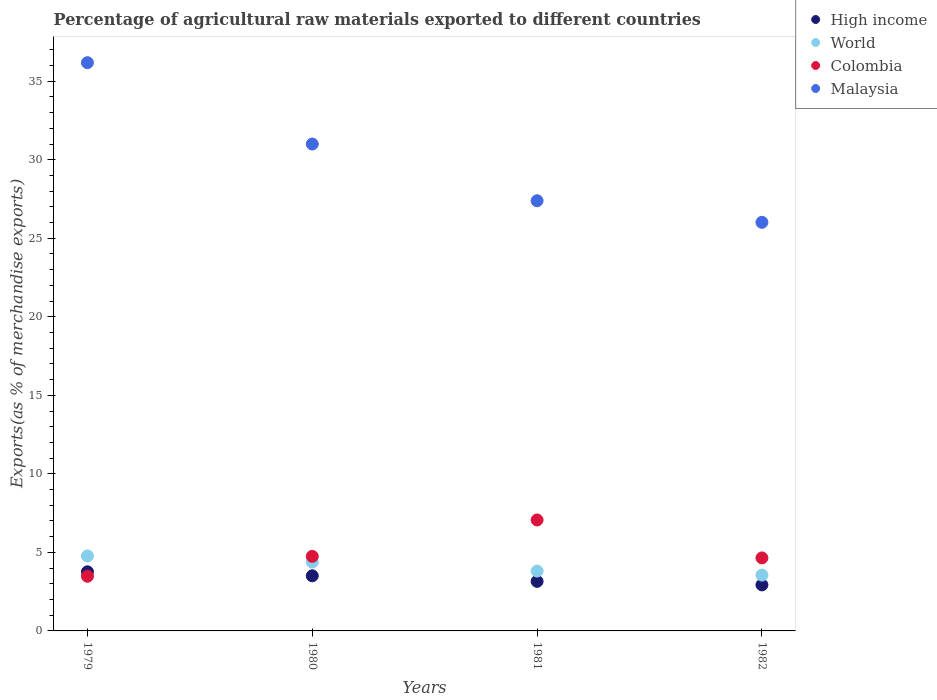How many different coloured dotlines are there?
Your answer should be compact. 4. Is the number of dotlines equal to the number of legend labels?
Keep it short and to the point. Yes. What is the percentage of exports to different countries in World in 1981?
Keep it short and to the point. 3.81. Across all years, what is the maximum percentage of exports to different countries in World?
Your response must be concise. 4.77. Across all years, what is the minimum percentage of exports to different countries in Malaysia?
Your answer should be very brief. 26.02. In which year was the percentage of exports to different countries in Malaysia maximum?
Your answer should be compact. 1979. In which year was the percentage of exports to different countries in High income minimum?
Your answer should be very brief. 1982. What is the total percentage of exports to different countries in Colombia in the graph?
Give a very brief answer. 19.94. What is the difference between the percentage of exports to different countries in World in 1979 and that in 1981?
Make the answer very short. 0.96. What is the difference between the percentage of exports to different countries in Colombia in 1979 and the percentage of exports to different countries in World in 1982?
Your answer should be compact. -0.07. What is the average percentage of exports to different countries in High income per year?
Your answer should be compact. 3.34. In the year 1982, what is the difference between the percentage of exports to different countries in High income and percentage of exports to different countries in Malaysia?
Your answer should be compact. -23.09. In how many years, is the percentage of exports to different countries in High income greater than 16 %?
Your response must be concise. 0. What is the ratio of the percentage of exports to different countries in World in 1979 to that in 1982?
Keep it short and to the point. 1.34. Is the percentage of exports to different countries in High income in 1979 less than that in 1982?
Offer a terse response. No. Is the difference between the percentage of exports to different countries in High income in 1979 and 1982 greater than the difference between the percentage of exports to different countries in Malaysia in 1979 and 1982?
Your response must be concise. No. What is the difference between the highest and the second highest percentage of exports to different countries in Colombia?
Ensure brevity in your answer.  2.32. What is the difference between the highest and the lowest percentage of exports to different countries in High income?
Offer a very short reply. 0.83. In how many years, is the percentage of exports to different countries in High income greater than the average percentage of exports to different countries in High income taken over all years?
Offer a terse response. 2. Is the sum of the percentage of exports to different countries in Malaysia in 1980 and 1981 greater than the maximum percentage of exports to different countries in World across all years?
Ensure brevity in your answer.  Yes. Is it the case that in every year, the sum of the percentage of exports to different countries in World and percentage of exports to different countries in Malaysia  is greater than the sum of percentage of exports to different countries in High income and percentage of exports to different countries in Colombia?
Make the answer very short. No. How many dotlines are there?
Make the answer very short. 4. How many years are there in the graph?
Provide a succinct answer. 4. What is the difference between two consecutive major ticks on the Y-axis?
Offer a terse response. 5. Are the values on the major ticks of Y-axis written in scientific E-notation?
Your answer should be very brief. No. Does the graph contain any zero values?
Provide a succinct answer. No. Does the graph contain grids?
Offer a very short reply. No. Where does the legend appear in the graph?
Offer a very short reply. Top right. How many legend labels are there?
Offer a very short reply. 4. How are the legend labels stacked?
Your answer should be compact. Vertical. What is the title of the graph?
Keep it short and to the point. Percentage of agricultural raw materials exported to different countries. What is the label or title of the X-axis?
Your response must be concise. Years. What is the label or title of the Y-axis?
Provide a succinct answer. Exports(as % of merchandise exports). What is the Exports(as % of merchandise exports) in High income in 1979?
Your response must be concise. 3.76. What is the Exports(as % of merchandise exports) in World in 1979?
Offer a very short reply. 4.77. What is the Exports(as % of merchandise exports) in Colombia in 1979?
Ensure brevity in your answer.  3.48. What is the Exports(as % of merchandise exports) in Malaysia in 1979?
Your response must be concise. 36.18. What is the Exports(as % of merchandise exports) of High income in 1980?
Make the answer very short. 3.51. What is the Exports(as % of merchandise exports) of World in 1980?
Give a very brief answer. 4.38. What is the Exports(as % of merchandise exports) of Colombia in 1980?
Your answer should be very brief. 4.75. What is the Exports(as % of merchandise exports) in Malaysia in 1980?
Make the answer very short. 31. What is the Exports(as % of merchandise exports) of High income in 1981?
Provide a succinct answer. 3.16. What is the Exports(as % of merchandise exports) in World in 1981?
Your answer should be compact. 3.81. What is the Exports(as % of merchandise exports) of Colombia in 1981?
Ensure brevity in your answer.  7.07. What is the Exports(as % of merchandise exports) in Malaysia in 1981?
Ensure brevity in your answer.  27.39. What is the Exports(as % of merchandise exports) of High income in 1982?
Provide a succinct answer. 2.93. What is the Exports(as % of merchandise exports) of World in 1982?
Your answer should be compact. 3.55. What is the Exports(as % of merchandise exports) in Colombia in 1982?
Your answer should be very brief. 4.65. What is the Exports(as % of merchandise exports) in Malaysia in 1982?
Your answer should be compact. 26.02. Across all years, what is the maximum Exports(as % of merchandise exports) in High income?
Ensure brevity in your answer.  3.76. Across all years, what is the maximum Exports(as % of merchandise exports) in World?
Your response must be concise. 4.77. Across all years, what is the maximum Exports(as % of merchandise exports) of Colombia?
Your response must be concise. 7.07. Across all years, what is the maximum Exports(as % of merchandise exports) of Malaysia?
Keep it short and to the point. 36.18. Across all years, what is the minimum Exports(as % of merchandise exports) of High income?
Offer a very short reply. 2.93. Across all years, what is the minimum Exports(as % of merchandise exports) in World?
Make the answer very short. 3.55. Across all years, what is the minimum Exports(as % of merchandise exports) of Colombia?
Offer a terse response. 3.48. Across all years, what is the minimum Exports(as % of merchandise exports) of Malaysia?
Provide a succinct answer. 26.02. What is the total Exports(as % of merchandise exports) of High income in the graph?
Your response must be concise. 13.36. What is the total Exports(as % of merchandise exports) in World in the graph?
Keep it short and to the point. 16.52. What is the total Exports(as % of merchandise exports) in Colombia in the graph?
Provide a succinct answer. 19.94. What is the total Exports(as % of merchandise exports) of Malaysia in the graph?
Provide a succinct answer. 120.59. What is the difference between the Exports(as % of merchandise exports) in High income in 1979 and that in 1980?
Provide a short and direct response. 0.26. What is the difference between the Exports(as % of merchandise exports) of World in 1979 and that in 1980?
Offer a very short reply. 0.39. What is the difference between the Exports(as % of merchandise exports) of Colombia in 1979 and that in 1980?
Keep it short and to the point. -1.27. What is the difference between the Exports(as % of merchandise exports) of Malaysia in 1979 and that in 1980?
Make the answer very short. 5.18. What is the difference between the Exports(as % of merchandise exports) in High income in 1979 and that in 1981?
Give a very brief answer. 0.61. What is the difference between the Exports(as % of merchandise exports) in World in 1979 and that in 1981?
Provide a succinct answer. 0.96. What is the difference between the Exports(as % of merchandise exports) in Colombia in 1979 and that in 1981?
Make the answer very short. -3.58. What is the difference between the Exports(as % of merchandise exports) in Malaysia in 1979 and that in 1981?
Offer a very short reply. 8.79. What is the difference between the Exports(as % of merchandise exports) in High income in 1979 and that in 1982?
Give a very brief answer. 0.83. What is the difference between the Exports(as % of merchandise exports) of World in 1979 and that in 1982?
Make the answer very short. 1.22. What is the difference between the Exports(as % of merchandise exports) of Colombia in 1979 and that in 1982?
Provide a succinct answer. -1.17. What is the difference between the Exports(as % of merchandise exports) in Malaysia in 1979 and that in 1982?
Your answer should be compact. 10.16. What is the difference between the Exports(as % of merchandise exports) of High income in 1980 and that in 1981?
Ensure brevity in your answer.  0.35. What is the difference between the Exports(as % of merchandise exports) in World in 1980 and that in 1981?
Offer a very short reply. 0.57. What is the difference between the Exports(as % of merchandise exports) of Colombia in 1980 and that in 1981?
Provide a short and direct response. -2.32. What is the difference between the Exports(as % of merchandise exports) in Malaysia in 1980 and that in 1981?
Keep it short and to the point. 3.61. What is the difference between the Exports(as % of merchandise exports) of High income in 1980 and that in 1982?
Keep it short and to the point. 0.58. What is the difference between the Exports(as % of merchandise exports) of World in 1980 and that in 1982?
Provide a short and direct response. 0.83. What is the difference between the Exports(as % of merchandise exports) in Colombia in 1980 and that in 1982?
Provide a short and direct response. 0.1. What is the difference between the Exports(as % of merchandise exports) of Malaysia in 1980 and that in 1982?
Give a very brief answer. 4.98. What is the difference between the Exports(as % of merchandise exports) of High income in 1981 and that in 1982?
Provide a short and direct response. 0.23. What is the difference between the Exports(as % of merchandise exports) in World in 1981 and that in 1982?
Your answer should be compact. 0.26. What is the difference between the Exports(as % of merchandise exports) of Colombia in 1981 and that in 1982?
Give a very brief answer. 2.42. What is the difference between the Exports(as % of merchandise exports) of Malaysia in 1981 and that in 1982?
Your answer should be compact. 1.37. What is the difference between the Exports(as % of merchandise exports) in High income in 1979 and the Exports(as % of merchandise exports) in World in 1980?
Your answer should be compact. -0.62. What is the difference between the Exports(as % of merchandise exports) in High income in 1979 and the Exports(as % of merchandise exports) in Colombia in 1980?
Offer a very short reply. -0.98. What is the difference between the Exports(as % of merchandise exports) of High income in 1979 and the Exports(as % of merchandise exports) of Malaysia in 1980?
Provide a succinct answer. -27.24. What is the difference between the Exports(as % of merchandise exports) in World in 1979 and the Exports(as % of merchandise exports) in Colombia in 1980?
Give a very brief answer. 0.03. What is the difference between the Exports(as % of merchandise exports) in World in 1979 and the Exports(as % of merchandise exports) in Malaysia in 1980?
Make the answer very short. -26.23. What is the difference between the Exports(as % of merchandise exports) in Colombia in 1979 and the Exports(as % of merchandise exports) in Malaysia in 1980?
Ensure brevity in your answer.  -27.52. What is the difference between the Exports(as % of merchandise exports) of High income in 1979 and the Exports(as % of merchandise exports) of World in 1981?
Make the answer very short. -0.05. What is the difference between the Exports(as % of merchandise exports) in High income in 1979 and the Exports(as % of merchandise exports) in Colombia in 1981?
Ensure brevity in your answer.  -3.3. What is the difference between the Exports(as % of merchandise exports) of High income in 1979 and the Exports(as % of merchandise exports) of Malaysia in 1981?
Make the answer very short. -23.63. What is the difference between the Exports(as % of merchandise exports) of World in 1979 and the Exports(as % of merchandise exports) of Colombia in 1981?
Offer a terse response. -2.29. What is the difference between the Exports(as % of merchandise exports) in World in 1979 and the Exports(as % of merchandise exports) in Malaysia in 1981?
Provide a succinct answer. -22.62. What is the difference between the Exports(as % of merchandise exports) of Colombia in 1979 and the Exports(as % of merchandise exports) of Malaysia in 1981?
Your answer should be compact. -23.91. What is the difference between the Exports(as % of merchandise exports) in High income in 1979 and the Exports(as % of merchandise exports) in World in 1982?
Give a very brief answer. 0.21. What is the difference between the Exports(as % of merchandise exports) in High income in 1979 and the Exports(as % of merchandise exports) in Colombia in 1982?
Provide a succinct answer. -0.88. What is the difference between the Exports(as % of merchandise exports) of High income in 1979 and the Exports(as % of merchandise exports) of Malaysia in 1982?
Your answer should be very brief. -22.25. What is the difference between the Exports(as % of merchandise exports) of World in 1979 and the Exports(as % of merchandise exports) of Colombia in 1982?
Provide a short and direct response. 0.13. What is the difference between the Exports(as % of merchandise exports) in World in 1979 and the Exports(as % of merchandise exports) in Malaysia in 1982?
Give a very brief answer. -21.24. What is the difference between the Exports(as % of merchandise exports) in Colombia in 1979 and the Exports(as % of merchandise exports) in Malaysia in 1982?
Make the answer very short. -22.54. What is the difference between the Exports(as % of merchandise exports) in High income in 1980 and the Exports(as % of merchandise exports) in World in 1981?
Ensure brevity in your answer.  -0.3. What is the difference between the Exports(as % of merchandise exports) of High income in 1980 and the Exports(as % of merchandise exports) of Colombia in 1981?
Provide a short and direct response. -3.56. What is the difference between the Exports(as % of merchandise exports) of High income in 1980 and the Exports(as % of merchandise exports) of Malaysia in 1981?
Your answer should be very brief. -23.88. What is the difference between the Exports(as % of merchandise exports) in World in 1980 and the Exports(as % of merchandise exports) in Colombia in 1981?
Ensure brevity in your answer.  -2.68. What is the difference between the Exports(as % of merchandise exports) in World in 1980 and the Exports(as % of merchandise exports) in Malaysia in 1981?
Your response must be concise. -23.01. What is the difference between the Exports(as % of merchandise exports) of Colombia in 1980 and the Exports(as % of merchandise exports) of Malaysia in 1981?
Keep it short and to the point. -22.64. What is the difference between the Exports(as % of merchandise exports) in High income in 1980 and the Exports(as % of merchandise exports) in World in 1982?
Give a very brief answer. -0.05. What is the difference between the Exports(as % of merchandise exports) of High income in 1980 and the Exports(as % of merchandise exports) of Colombia in 1982?
Give a very brief answer. -1.14. What is the difference between the Exports(as % of merchandise exports) in High income in 1980 and the Exports(as % of merchandise exports) in Malaysia in 1982?
Your response must be concise. -22.51. What is the difference between the Exports(as % of merchandise exports) of World in 1980 and the Exports(as % of merchandise exports) of Colombia in 1982?
Your answer should be compact. -0.27. What is the difference between the Exports(as % of merchandise exports) of World in 1980 and the Exports(as % of merchandise exports) of Malaysia in 1982?
Keep it short and to the point. -21.63. What is the difference between the Exports(as % of merchandise exports) in Colombia in 1980 and the Exports(as % of merchandise exports) in Malaysia in 1982?
Your answer should be very brief. -21.27. What is the difference between the Exports(as % of merchandise exports) of High income in 1981 and the Exports(as % of merchandise exports) of World in 1982?
Ensure brevity in your answer.  -0.4. What is the difference between the Exports(as % of merchandise exports) in High income in 1981 and the Exports(as % of merchandise exports) in Colombia in 1982?
Your response must be concise. -1.49. What is the difference between the Exports(as % of merchandise exports) of High income in 1981 and the Exports(as % of merchandise exports) of Malaysia in 1982?
Provide a short and direct response. -22.86. What is the difference between the Exports(as % of merchandise exports) in World in 1981 and the Exports(as % of merchandise exports) in Colombia in 1982?
Ensure brevity in your answer.  -0.84. What is the difference between the Exports(as % of merchandise exports) of World in 1981 and the Exports(as % of merchandise exports) of Malaysia in 1982?
Provide a succinct answer. -22.21. What is the difference between the Exports(as % of merchandise exports) of Colombia in 1981 and the Exports(as % of merchandise exports) of Malaysia in 1982?
Your answer should be very brief. -18.95. What is the average Exports(as % of merchandise exports) in High income per year?
Offer a very short reply. 3.34. What is the average Exports(as % of merchandise exports) of World per year?
Provide a short and direct response. 4.13. What is the average Exports(as % of merchandise exports) in Colombia per year?
Ensure brevity in your answer.  4.99. What is the average Exports(as % of merchandise exports) of Malaysia per year?
Provide a succinct answer. 30.15. In the year 1979, what is the difference between the Exports(as % of merchandise exports) of High income and Exports(as % of merchandise exports) of World?
Provide a succinct answer. -1.01. In the year 1979, what is the difference between the Exports(as % of merchandise exports) in High income and Exports(as % of merchandise exports) in Colombia?
Your answer should be compact. 0.28. In the year 1979, what is the difference between the Exports(as % of merchandise exports) in High income and Exports(as % of merchandise exports) in Malaysia?
Offer a terse response. -32.42. In the year 1979, what is the difference between the Exports(as % of merchandise exports) of World and Exports(as % of merchandise exports) of Colombia?
Your response must be concise. 1.29. In the year 1979, what is the difference between the Exports(as % of merchandise exports) of World and Exports(as % of merchandise exports) of Malaysia?
Provide a short and direct response. -31.41. In the year 1979, what is the difference between the Exports(as % of merchandise exports) in Colombia and Exports(as % of merchandise exports) in Malaysia?
Keep it short and to the point. -32.7. In the year 1980, what is the difference between the Exports(as % of merchandise exports) of High income and Exports(as % of merchandise exports) of World?
Give a very brief answer. -0.87. In the year 1980, what is the difference between the Exports(as % of merchandise exports) of High income and Exports(as % of merchandise exports) of Colombia?
Give a very brief answer. -1.24. In the year 1980, what is the difference between the Exports(as % of merchandise exports) of High income and Exports(as % of merchandise exports) of Malaysia?
Provide a short and direct response. -27.49. In the year 1980, what is the difference between the Exports(as % of merchandise exports) of World and Exports(as % of merchandise exports) of Colombia?
Provide a short and direct response. -0.36. In the year 1980, what is the difference between the Exports(as % of merchandise exports) in World and Exports(as % of merchandise exports) in Malaysia?
Your answer should be very brief. -26.62. In the year 1980, what is the difference between the Exports(as % of merchandise exports) in Colombia and Exports(as % of merchandise exports) in Malaysia?
Provide a short and direct response. -26.25. In the year 1981, what is the difference between the Exports(as % of merchandise exports) in High income and Exports(as % of merchandise exports) in World?
Provide a succinct answer. -0.65. In the year 1981, what is the difference between the Exports(as % of merchandise exports) of High income and Exports(as % of merchandise exports) of Colombia?
Provide a succinct answer. -3.91. In the year 1981, what is the difference between the Exports(as % of merchandise exports) in High income and Exports(as % of merchandise exports) in Malaysia?
Keep it short and to the point. -24.23. In the year 1981, what is the difference between the Exports(as % of merchandise exports) of World and Exports(as % of merchandise exports) of Colombia?
Make the answer very short. -3.25. In the year 1981, what is the difference between the Exports(as % of merchandise exports) of World and Exports(as % of merchandise exports) of Malaysia?
Offer a very short reply. -23.58. In the year 1981, what is the difference between the Exports(as % of merchandise exports) in Colombia and Exports(as % of merchandise exports) in Malaysia?
Offer a terse response. -20.33. In the year 1982, what is the difference between the Exports(as % of merchandise exports) of High income and Exports(as % of merchandise exports) of World?
Provide a short and direct response. -0.62. In the year 1982, what is the difference between the Exports(as % of merchandise exports) in High income and Exports(as % of merchandise exports) in Colombia?
Your answer should be compact. -1.72. In the year 1982, what is the difference between the Exports(as % of merchandise exports) in High income and Exports(as % of merchandise exports) in Malaysia?
Keep it short and to the point. -23.09. In the year 1982, what is the difference between the Exports(as % of merchandise exports) of World and Exports(as % of merchandise exports) of Colombia?
Your response must be concise. -1.09. In the year 1982, what is the difference between the Exports(as % of merchandise exports) of World and Exports(as % of merchandise exports) of Malaysia?
Provide a succinct answer. -22.46. In the year 1982, what is the difference between the Exports(as % of merchandise exports) in Colombia and Exports(as % of merchandise exports) in Malaysia?
Ensure brevity in your answer.  -21.37. What is the ratio of the Exports(as % of merchandise exports) of High income in 1979 to that in 1980?
Offer a terse response. 1.07. What is the ratio of the Exports(as % of merchandise exports) in World in 1979 to that in 1980?
Keep it short and to the point. 1.09. What is the ratio of the Exports(as % of merchandise exports) of Colombia in 1979 to that in 1980?
Your answer should be very brief. 0.73. What is the ratio of the Exports(as % of merchandise exports) in Malaysia in 1979 to that in 1980?
Offer a very short reply. 1.17. What is the ratio of the Exports(as % of merchandise exports) in High income in 1979 to that in 1981?
Keep it short and to the point. 1.19. What is the ratio of the Exports(as % of merchandise exports) of World in 1979 to that in 1981?
Give a very brief answer. 1.25. What is the ratio of the Exports(as % of merchandise exports) of Colombia in 1979 to that in 1981?
Make the answer very short. 0.49. What is the ratio of the Exports(as % of merchandise exports) in Malaysia in 1979 to that in 1981?
Your answer should be very brief. 1.32. What is the ratio of the Exports(as % of merchandise exports) in High income in 1979 to that in 1982?
Provide a short and direct response. 1.28. What is the ratio of the Exports(as % of merchandise exports) in World in 1979 to that in 1982?
Keep it short and to the point. 1.34. What is the ratio of the Exports(as % of merchandise exports) of Colombia in 1979 to that in 1982?
Offer a very short reply. 0.75. What is the ratio of the Exports(as % of merchandise exports) of Malaysia in 1979 to that in 1982?
Give a very brief answer. 1.39. What is the ratio of the Exports(as % of merchandise exports) in High income in 1980 to that in 1981?
Provide a short and direct response. 1.11. What is the ratio of the Exports(as % of merchandise exports) of World in 1980 to that in 1981?
Your answer should be compact. 1.15. What is the ratio of the Exports(as % of merchandise exports) in Colombia in 1980 to that in 1981?
Your response must be concise. 0.67. What is the ratio of the Exports(as % of merchandise exports) in Malaysia in 1980 to that in 1981?
Make the answer very short. 1.13. What is the ratio of the Exports(as % of merchandise exports) of High income in 1980 to that in 1982?
Offer a terse response. 1.2. What is the ratio of the Exports(as % of merchandise exports) of World in 1980 to that in 1982?
Offer a terse response. 1.23. What is the ratio of the Exports(as % of merchandise exports) of Colombia in 1980 to that in 1982?
Your response must be concise. 1.02. What is the ratio of the Exports(as % of merchandise exports) in Malaysia in 1980 to that in 1982?
Give a very brief answer. 1.19. What is the ratio of the Exports(as % of merchandise exports) of High income in 1981 to that in 1982?
Provide a short and direct response. 1.08. What is the ratio of the Exports(as % of merchandise exports) in World in 1981 to that in 1982?
Keep it short and to the point. 1.07. What is the ratio of the Exports(as % of merchandise exports) of Colombia in 1981 to that in 1982?
Offer a very short reply. 1.52. What is the ratio of the Exports(as % of merchandise exports) in Malaysia in 1981 to that in 1982?
Your response must be concise. 1.05. What is the difference between the highest and the second highest Exports(as % of merchandise exports) in High income?
Your answer should be very brief. 0.26. What is the difference between the highest and the second highest Exports(as % of merchandise exports) of World?
Keep it short and to the point. 0.39. What is the difference between the highest and the second highest Exports(as % of merchandise exports) of Colombia?
Offer a very short reply. 2.32. What is the difference between the highest and the second highest Exports(as % of merchandise exports) in Malaysia?
Your answer should be very brief. 5.18. What is the difference between the highest and the lowest Exports(as % of merchandise exports) in High income?
Your response must be concise. 0.83. What is the difference between the highest and the lowest Exports(as % of merchandise exports) of World?
Ensure brevity in your answer.  1.22. What is the difference between the highest and the lowest Exports(as % of merchandise exports) in Colombia?
Your response must be concise. 3.58. What is the difference between the highest and the lowest Exports(as % of merchandise exports) of Malaysia?
Your response must be concise. 10.16. 